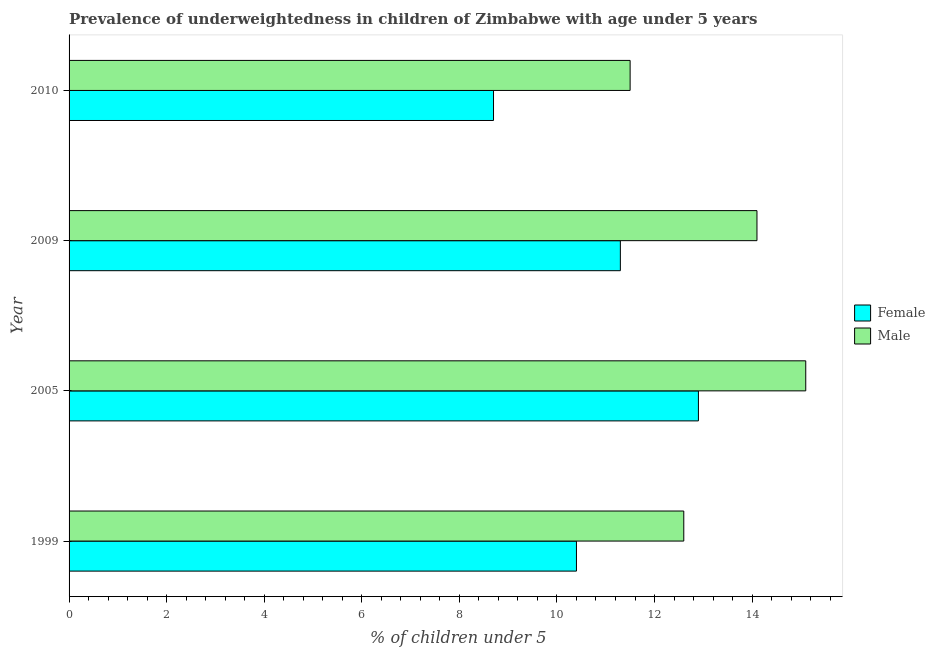How many bars are there on the 2nd tick from the top?
Keep it short and to the point. 2. In how many cases, is the number of bars for a given year not equal to the number of legend labels?
Give a very brief answer. 0. What is the percentage of underweighted female children in 1999?
Provide a short and direct response. 10.4. Across all years, what is the maximum percentage of underweighted female children?
Your answer should be compact. 12.9. Across all years, what is the minimum percentage of underweighted female children?
Ensure brevity in your answer.  8.7. What is the total percentage of underweighted male children in the graph?
Provide a short and direct response. 53.3. What is the difference between the percentage of underweighted male children in 2009 and the percentage of underweighted female children in 2005?
Give a very brief answer. 1.2. What is the average percentage of underweighted male children per year?
Ensure brevity in your answer.  13.32. In how many years, is the percentage of underweighted female children greater than 0.8 %?
Offer a very short reply. 4. What is the ratio of the percentage of underweighted male children in 1999 to that in 2010?
Give a very brief answer. 1.1. Is the percentage of underweighted male children in 1999 less than that in 2010?
Make the answer very short. No. Is the difference between the percentage of underweighted female children in 1999 and 2005 greater than the difference between the percentage of underweighted male children in 1999 and 2005?
Provide a short and direct response. No. In how many years, is the percentage of underweighted male children greater than the average percentage of underweighted male children taken over all years?
Your answer should be very brief. 2. Is the sum of the percentage of underweighted female children in 2005 and 2010 greater than the maximum percentage of underweighted male children across all years?
Ensure brevity in your answer.  Yes. Are all the bars in the graph horizontal?
Your answer should be very brief. Yes. Does the graph contain grids?
Provide a succinct answer. No. What is the title of the graph?
Make the answer very short. Prevalence of underweightedness in children of Zimbabwe with age under 5 years. What is the label or title of the X-axis?
Your answer should be very brief.  % of children under 5. What is the  % of children under 5 in Female in 1999?
Offer a very short reply. 10.4. What is the  % of children under 5 in Male in 1999?
Offer a very short reply. 12.6. What is the  % of children under 5 of Female in 2005?
Ensure brevity in your answer.  12.9. What is the  % of children under 5 of Male in 2005?
Make the answer very short. 15.1. What is the  % of children under 5 of Female in 2009?
Offer a very short reply. 11.3. What is the  % of children under 5 in Male in 2009?
Offer a terse response. 14.1. What is the  % of children under 5 of Female in 2010?
Offer a terse response. 8.7. What is the  % of children under 5 in Male in 2010?
Your answer should be compact. 11.5. Across all years, what is the maximum  % of children under 5 in Female?
Provide a short and direct response. 12.9. Across all years, what is the maximum  % of children under 5 in Male?
Your answer should be compact. 15.1. Across all years, what is the minimum  % of children under 5 in Female?
Keep it short and to the point. 8.7. Across all years, what is the minimum  % of children under 5 in Male?
Your answer should be compact. 11.5. What is the total  % of children under 5 in Female in the graph?
Keep it short and to the point. 43.3. What is the total  % of children under 5 in Male in the graph?
Your response must be concise. 53.3. What is the difference between the  % of children under 5 in Female in 1999 and that in 2010?
Offer a terse response. 1.7. What is the difference between the  % of children under 5 in Male in 1999 and that in 2010?
Provide a short and direct response. 1.1. What is the difference between the  % of children under 5 of Female in 1999 and the  % of children under 5 of Male in 2009?
Offer a very short reply. -3.7. What is the average  % of children under 5 of Female per year?
Your response must be concise. 10.82. What is the average  % of children under 5 in Male per year?
Your response must be concise. 13.32. In the year 2005, what is the difference between the  % of children under 5 in Female and  % of children under 5 in Male?
Offer a very short reply. -2.2. What is the ratio of the  % of children under 5 in Female in 1999 to that in 2005?
Make the answer very short. 0.81. What is the ratio of the  % of children under 5 in Male in 1999 to that in 2005?
Your response must be concise. 0.83. What is the ratio of the  % of children under 5 of Female in 1999 to that in 2009?
Ensure brevity in your answer.  0.92. What is the ratio of the  % of children under 5 of Male in 1999 to that in 2009?
Make the answer very short. 0.89. What is the ratio of the  % of children under 5 of Female in 1999 to that in 2010?
Offer a very short reply. 1.2. What is the ratio of the  % of children under 5 in Male in 1999 to that in 2010?
Your answer should be compact. 1.1. What is the ratio of the  % of children under 5 of Female in 2005 to that in 2009?
Make the answer very short. 1.14. What is the ratio of the  % of children under 5 in Male in 2005 to that in 2009?
Keep it short and to the point. 1.07. What is the ratio of the  % of children under 5 of Female in 2005 to that in 2010?
Ensure brevity in your answer.  1.48. What is the ratio of the  % of children under 5 in Male in 2005 to that in 2010?
Ensure brevity in your answer.  1.31. What is the ratio of the  % of children under 5 of Female in 2009 to that in 2010?
Your response must be concise. 1.3. What is the ratio of the  % of children under 5 in Male in 2009 to that in 2010?
Give a very brief answer. 1.23. What is the difference between the highest and the second highest  % of children under 5 in Female?
Your answer should be compact. 1.6. What is the difference between the highest and the lowest  % of children under 5 of Male?
Offer a terse response. 3.6. 